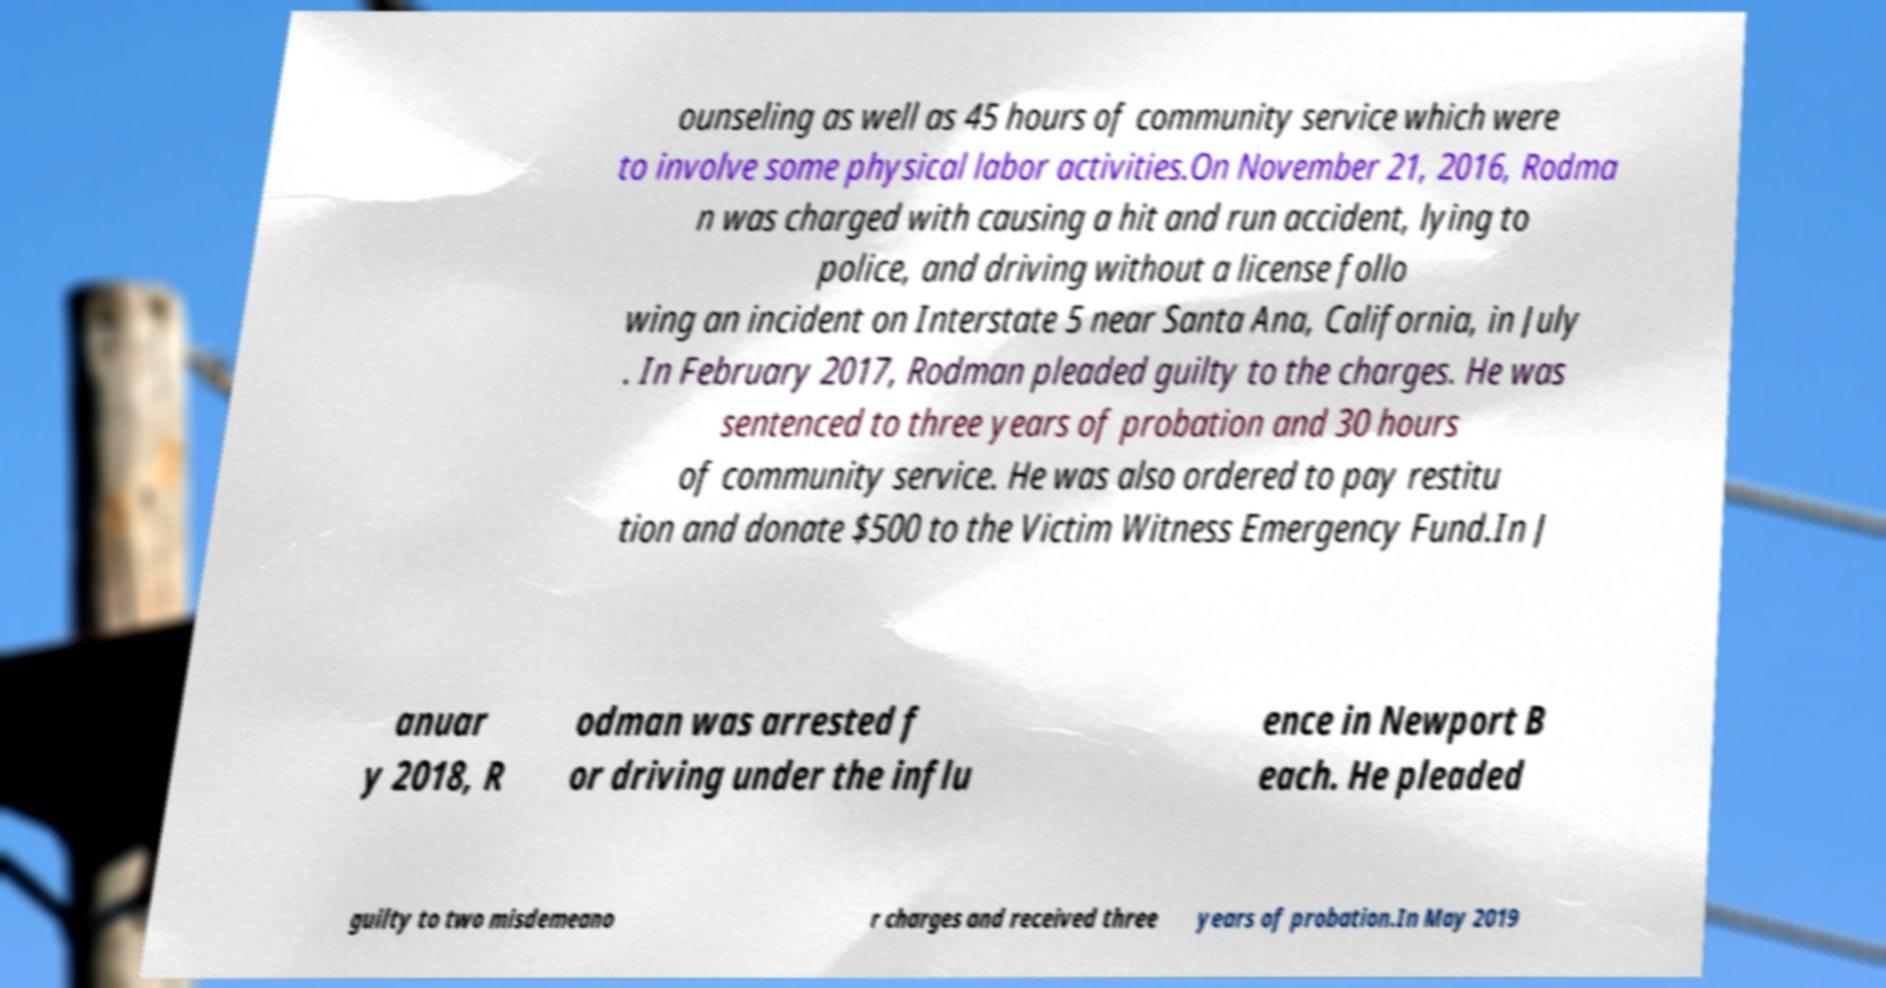I need the written content from this picture converted into text. Can you do that? ounseling as well as 45 hours of community service which were to involve some physical labor activities.On November 21, 2016, Rodma n was charged with causing a hit and run accident, lying to police, and driving without a license follo wing an incident on Interstate 5 near Santa Ana, California, in July . In February 2017, Rodman pleaded guilty to the charges. He was sentenced to three years of probation and 30 hours of community service. He was also ordered to pay restitu tion and donate $500 to the Victim Witness Emergency Fund.In J anuar y 2018, R odman was arrested f or driving under the influ ence in Newport B each. He pleaded guilty to two misdemeano r charges and received three years of probation.In May 2019 